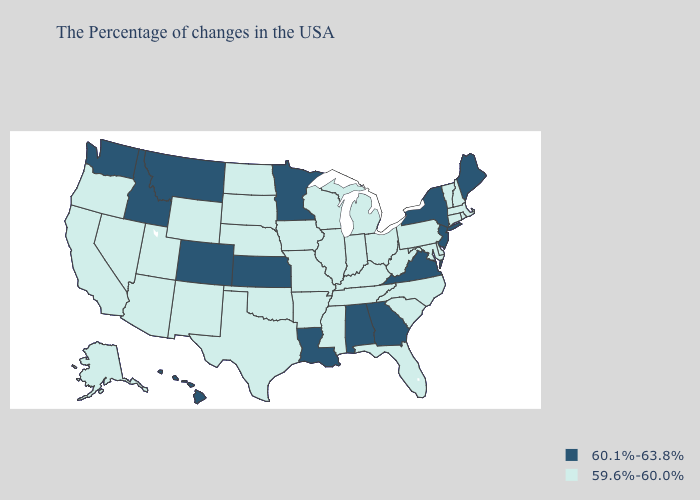Name the states that have a value in the range 59.6%-60.0%?
Answer briefly. Massachusetts, Rhode Island, New Hampshire, Vermont, Connecticut, Delaware, Maryland, Pennsylvania, North Carolina, South Carolina, West Virginia, Ohio, Florida, Michigan, Kentucky, Indiana, Tennessee, Wisconsin, Illinois, Mississippi, Missouri, Arkansas, Iowa, Nebraska, Oklahoma, Texas, South Dakota, North Dakota, Wyoming, New Mexico, Utah, Arizona, Nevada, California, Oregon, Alaska. What is the highest value in the Northeast ?
Quick response, please. 60.1%-63.8%. Does the map have missing data?
Keep it brief. No. Name the states that have a value in the range 60.1%-63.8%?
Be succinct. Maine, New York, New Jersey, Virginia, Georgia, Alabama, Louisiana, Minnesota, Kansas, Colorado, Montana, Idaho, Washington, Hawaii. What is the value of Georgia?
Concise answer only. 60.1%-63.8%. Among the states that border Wisconsin , which have the lowest value?
Concise answer only. Michigan, Illinois, Iowa. Name the states that have a value in the range 59.6%-60.0%?
Be succinct. Massachusetts, Rhode Island, New Hampshire, Vermont, Connecticut, Delaware, Maryland, Pennsylvania, North Carolina, South Carolina, West Virginia, Ohio, Florida, Michigan, Kentucky, Indiana, Tennessee, Wisconsin, Illinois, Mississippi, Missouri, Arkansas, Iowa, Nebraska, Oklahoma, Texas, South Dakota, North Dakota, Wyoming, New Mexico, Utah, Arizona, Nevada, California, Oregon, Alaska. Does Louisiana have the same value as Tennessee?
Write a very short answer. No. How many symbols are there in the legend?
Write a very short answer. 2. What is the value of North Dakota?
Answer briefly. 59.6%-60.0%. Which states hav the highest value in the Northeast?
Quick response, please. Maine, New York, New Jersey. What is the value of Minnesota?
Give a very brief answer. 60.1%-63.8%. Name the states that have a value in the range 59.6%-60.0%?
Give a very brief answer. Massachusetts, Rhode Island, New Hampshire, Vermont, Connecticut, Delaware, Maryland, Pennsylvania, North Carolina, South Carolina, West Virginia, Ohio, Florida, Michigan, Kentucky, Indiana, Tennessee, Wisconsin, Illinois, Mississippi, Missouri, Arkansas, Iowa, Nebraska, Oklahoma, Texas, South Dakota, North Dakota, Wyoming, New Mexico, Utah, Arizona, Nevada, California, Oregon, Alaska. Does Alabama have the highest value in the South?
Keep it brief. Yes. Does Pennsylvania have a lower value than Florida?
Answer briefly. No. 